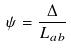<formula> <loc_0><loc_0><loc_500><loc_500>\psi = \frac { \Delta } { L _ { a b } }</formula> 